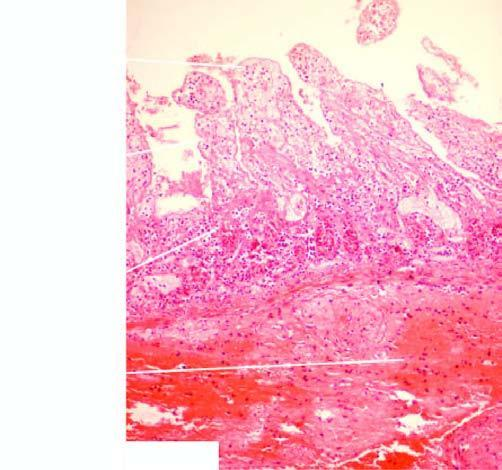s peripheral blood in itp marked at the line of demarcation between the infarcted and normal bowel?
Answer the question using a single word or phrase. No 